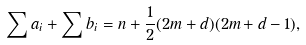Convert formula to latex. <formula><loc_0><loc_0><loc_500><loc_500>\sum a _ { i } + \sum b _ { i } = n + \frac { 1 } { 2 } ( 2 m + d ) ( 2 m + d - 1 ) ,</formula> 